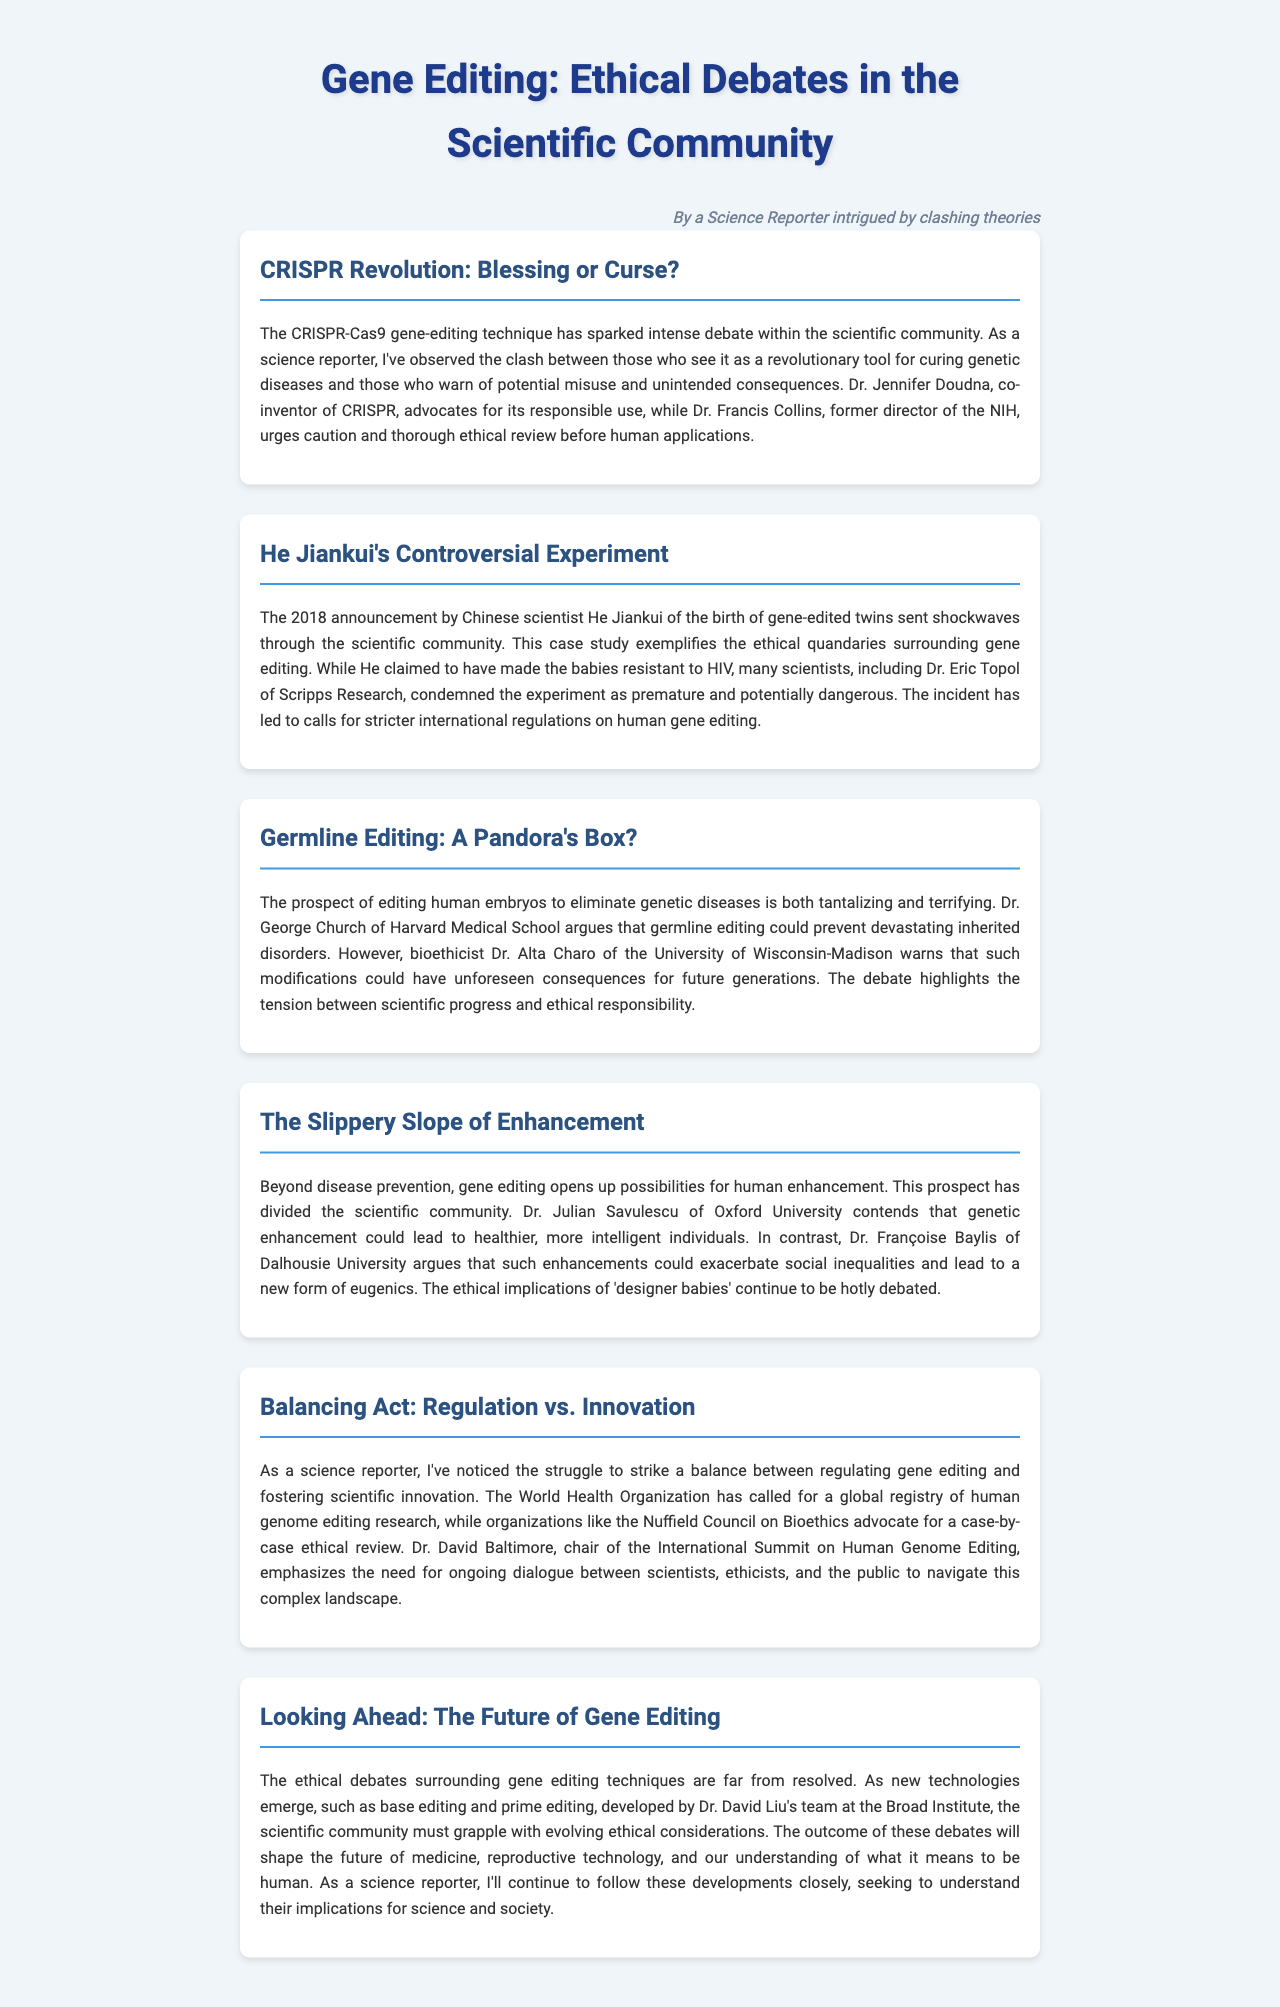What is the title of the newsletter? The title of the newsletter is presented at the top of the document, encapsulating the main theme discussed throughout.
Answer: Gene Editing: Ethical Debates in the Scientific Community Who is a co-inventor of CRISPR? The document identifies specific individuals associated with the development of CRISPR, highlighting their contributions.
Answer: Dr. Jennifer Doudna What year did He Jiankui announce the birth of gene-edited twins? This is a crucial date mentioned in the document that marks a significant event in the field of gene editing.
Answer: 2018 Which organization called for a global registry of human genome editing research? The document references an organization that advocates for transparency and oversight in gene editing practices.
Answer: World Health Organization What is a potential consequence of germline editing according to Dr. Alta Charo? This highlights the ethical concerns presented by a prominent bioethicist regarding the implications of editing human embryos.
Answer: Unforeseen consequences Which bioethicist argues that genetic enhancement could lead to social inequalities? The document mentions differing opinions among bioethicists regarding the implications of gene editing beyond disease prevention.
Answer: Dr. Françoise Baylis What does Dr. David Baltimore emphasize is necessary for navigating gene editing debates? This addresses the importance of dialogue in the context of scientific innovation and ethical considerations surrounding gene editing.
Answer: Ongoing dialogue What are base editing and prime editing considered? The document discusses emerging gene editing technologies that may influence future ethical discussions.
Answer: New technologies Which scientist’s team developed base editing and prime editing? This points to a specific individual recognized for their contributions to advanced gene editing techniques within the scientific community.
Answer: Dr. David Liu 